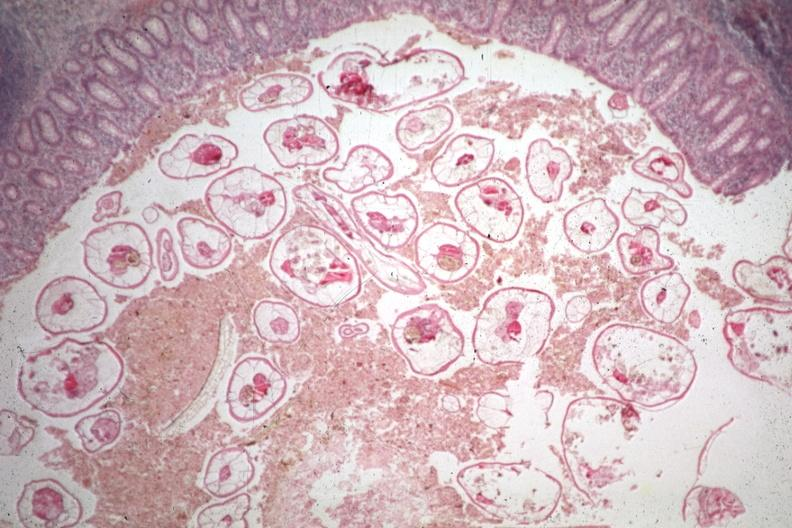s normal ovary present?
Answer the question using a single word or phrase. No 